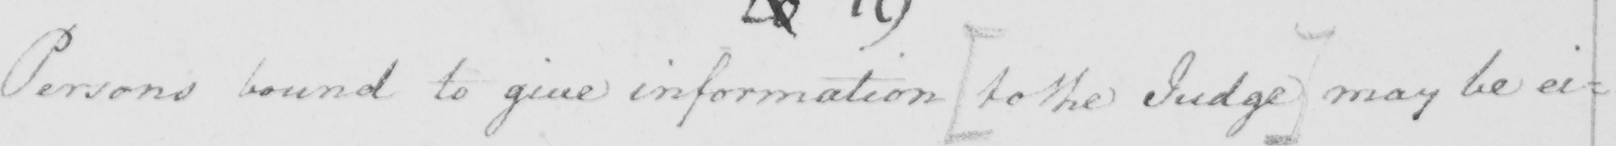What is written in this line of handwriting? Persons bound to give information  [ to the Judge ]  may be ei= 